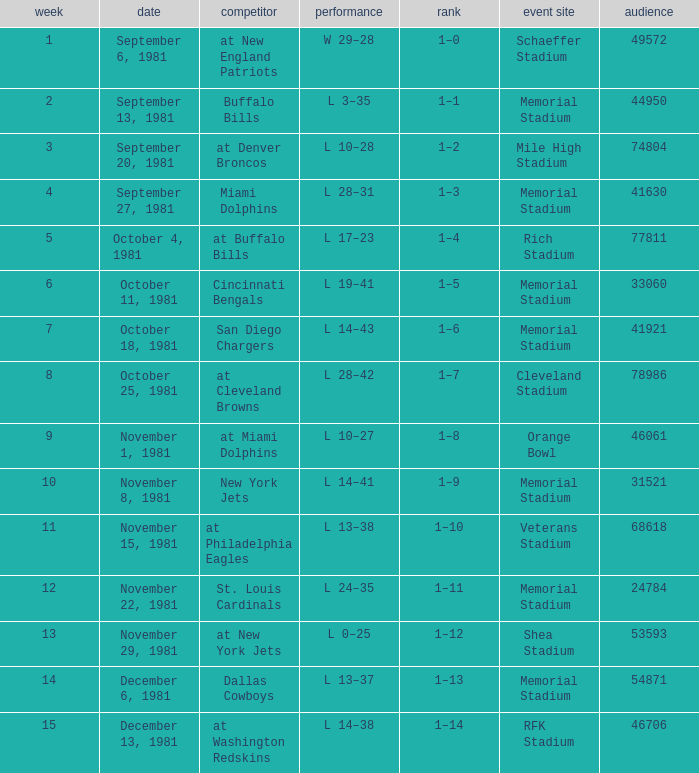When it is October 18, 1981 where is the game site? Memorial Stadium. 